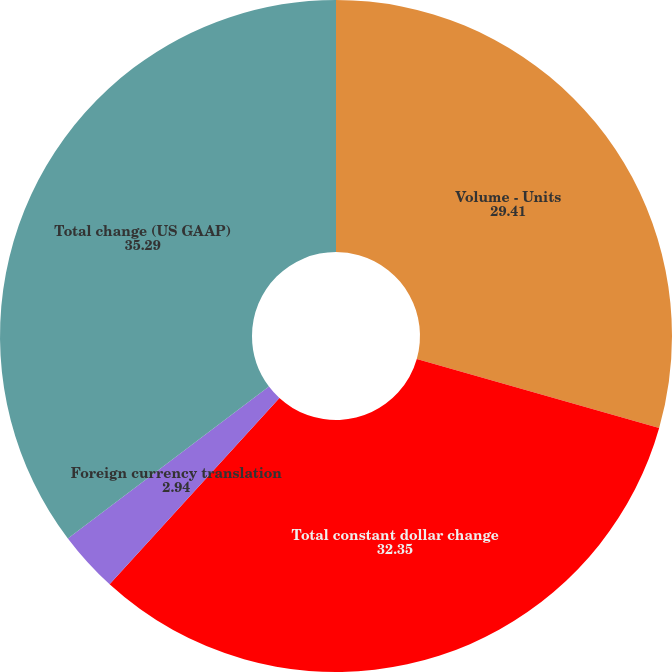Convert chart to OTSL. <chart><loc_0><loc_0><loc_500><loc_500><pie_chart><fcel>Volume - Units<fcel>Total constant dollar change<fcel>Foreign currency translation<fcel>Total change (US GAAP)<nl><fcel>29.41%<fcel>32.35%<fcel>2.94%<fcel>35.29%<nl></chart> 